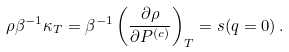Convert formula to latex. <formula><loc_0><loc_0><loc_500><loc_500>\rho \beta ^ { - 1 } \kappa _ { T } = \beta ^ { - 1 } \left ( \frac { \partial \rho } { \partial P ^ { ( c ) } } \right ) _ { T } = s ( q = 0 ) \, .</formula> 